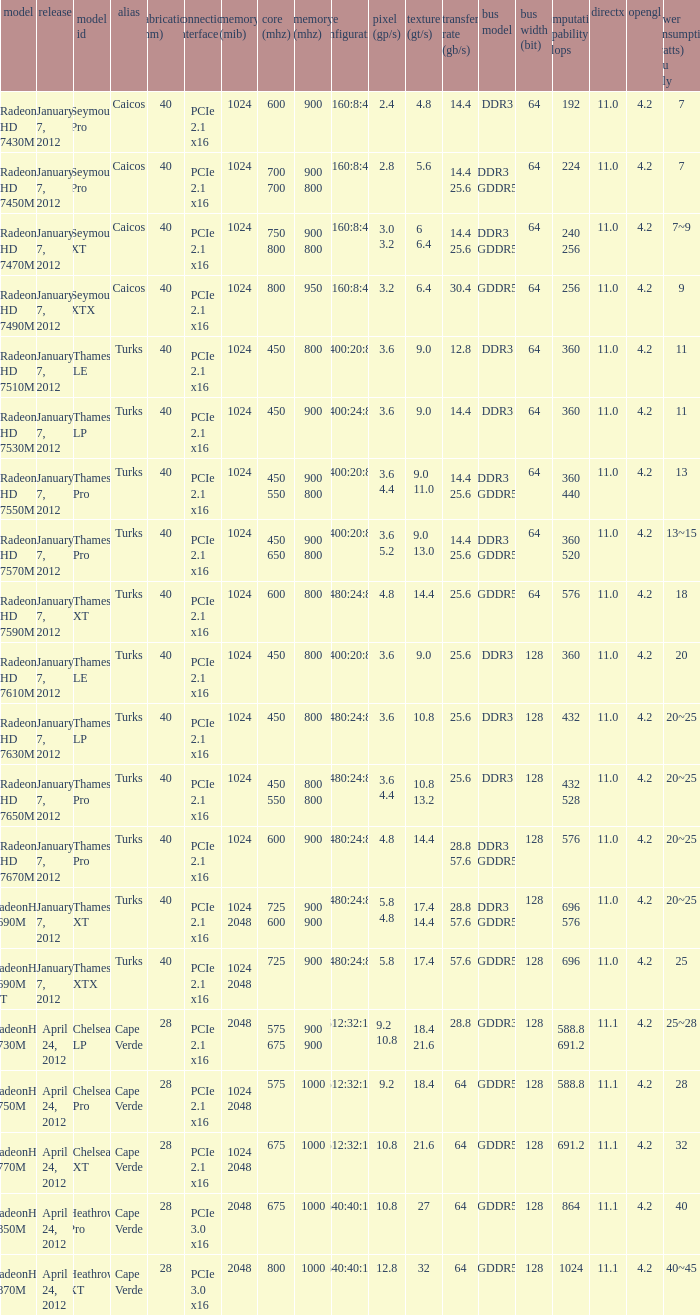I'm looking to parse the entire table for insights. Could you assist me with that? {'header': ['model', 'release', 'model id', 'alias', 'fabrication (nm)', 'connection interface', 'memory (mib)', 'core (mhz)', 'memory (mhz)', 'core configuration', 'pixel (gp/s)', 'texture (gt/s)', 'transfer rate (gb/s)', 'bus model', 'bus width (bit)', 'computation capability gflops', 'directx', 'opengl', 'power consumption (watts) gpu only'], 'rows': [['Radeon HD 7430M', 'January 7, 2012', 'Seymour Pro', 'Caicos', '40', 'PCIe 2.1 x16', '1024', '600', '900', '160:8:4', '2.4', '4.8', '14.4', 'DDR3', '64', '192', '11.0', '4.2', '7'], ['Radeon HD 7450M', 'January 7, 2012', 'Seymour Pro', 'Caicos', '40', 'PCIe 2.1 x16', '1024', '700 700', '900 800', '160:8:4', '2.8', '5.6', '14.4 25.6', 'DDR3 GDDR5', '64', '224', '11.0', '4.2', '7'], ['Radeon HD 7470M', 'January 7, 2012', 'Seymour XT', 'Caicos', '40', 'PCIe 2.1 x16', '1024', '750 800', '900 800', '160:8:4', '3.0 3.2', '6 6.4', '14.4 25.6', 'DDR3 GDDR5', '64', '240 256', '11.0', '4.2', '7~9'], ['Radeon HD 7490M', 'January 7, 2012', 'Seymour XTX', 'Caicos', '40', 'PCIe 2.1 x16', '1024', '800', '950', '160:8:4', '3.2', '6.4', '30.4', 'GDDR5', '64', '256', '11.0', '4.2', '9'], ['Radeon HD 7510M', 'January 7, 2012', 'Thames LE', 'Turks', '40', 'PCIe 2.1 x16', '1024', '450', '800', '400:20:8', '3.6', '9.0', '12.8', 'DDR3', '64', '360', '11.0', '4.2', '11'], ['Radeon HD 7530M', 'January 7, 2012', 'Thames LP', 'Turks', '40', 'PCIe 2.1 x16', '1024', '450', '900', '400:24:8', '3.6', '9.0', '14.4', 'DDR3', '64', '360', '11.0', '4.2', '11'], ['Radeon HD 7550M', 'January 7, 2012', 'Thames Pro', 'Turks', '40', 'PCIe 2.1 x16', '1024', '450 550', '900 800', '400:20:8', '3.6 4.4', '9.0 11.0', '14.4 25.6', 'DDR3 GDDR5', '64', '360 440', '11.0', '4.2', '13'], ['Radeon HD 7570M', 'January 7, 2012', 'Thames Pro', 'Turks', '40', 'PCIe 2.1 x16', '1024', '450 650', '900 800', '400:20:8', '3.6 5.2', '9.0 13.0', '14.4 25.6', 'DDR3 GDDR5', '64', '360 520', '11.0', '4.2', '13~15'], ['Radeon HD 7590M', 'January 7, 2012', 'Thames XT', 'Turks', '40', 'PCIe 2.1 x16', '1024', '600', '800', '480:24:8', '4.8', '14.4', '25.6', 'GDDR5', '64', '576', '11.0', '4.2', '18'], ['Radeon HD 7610M', 'January 7, 2012', 'Thames LE', 'Turks', '40', 'PCIe 2.1 x16', '1024', '450', '800', '400:20:8', '3.6', '9.0', '25.6', 'DDR3', '128', '360', '11.0', '4.2', '20'], ['Radeon HD 7630M', 'January 7, 2012', 'Thames LP', 'Turks', '40', 'PCIe 2.1 x16', '1024', '450', '800', '480:24:8', '3.6', '10.8', '25.6', 'DDR3', '128', '432', '11.0', '4.2', '20~25'], ['Radeon HD 7650M', 'January 7, 2012', 'Thames Pro', 'Turks', '40', 'PCIe 2.1 x16', '1024', '450 550', '800 800', '480:24:8', '3.6 4.4', '10.8 13.2', '25.6', 'DDR3', '128', '432 528', '11.0', '4.2', '20~25'], ['Radeon HD 7670M', 'January 7, 2012', 'Thames Pro', 'Turks', '40', 'PCIe 2.1 x16', '1024', '600', '900', '480:24:8', '4.8', '14.4', '28.8 57.6', 'DDR3 GDDR5', '128', '576', '11.0', '4.2', '20~25'], ['RadeonHD 7690M', 'January 7, 2012', 'Thames XT', 'Turks', '40', 'PCIe 2.1 x16', '1024 2048', '725 600', '900 900', '480:24:8', '5.8 4.8', '17.4 14.4', '28.8 57.6', 'DDR3 GDDR5', '128', '696 576', '11.0', '4.2', '20~25'], ['RadeonHD 7690M XT', 'January 7, 2012', 'Thames XTX', 'Turks', '40', 'PCIe 2.1 x16', '1024 2048', '725', '900', '480:24:8', '5.8', '17.4', '57.6', 'GDDR5', '128', '696', '11.0', '4.2', '25'], ['RadeonHD 7730M', 'April 24, 2012', 'Chelsea LP', 'Cape Verde', '28', 'PCIe 2.1 x16', '2048', '575 675', '900 900', '512:32:16', '9.2 10.8', '18.4 21.6', '28.8', 'GDDR3', '128', '588.8 691.2', '11.1', '4.2', '25~28'], ['RadeonHD 7750M', 'April 24, 2012', 'Chelsea Pro', 'Cape Verde', '28', 'PCIe 2.1 x16', '1024 2048', '575', '1000', '512:32:16', '9.2', '18.4', '64', 'GDDR5', '128', '588.8', '11.1', '4.2', '28'], ['RadeonHD 7770M', 'April 24, 2012', 'Chelsea XT', 'Cape Verde', '28', 'PCIe 2.1 x16', '1024 2048', '675', '1000', '512:32:16', '10.8', '21.6', '64', 'GDDR5', '128', '691.2', '11.1', '4.2', '32'], ['RadeonHD 7850M', 'April 24, 2012', 'Heathrow Pro', 'Cape Verde', '28', 'PCIe 3.0 x16', '2048', '675', '1000', '640:40:16', '10.8', '27', '64', 'GDDR5', '128', '864', '11.1', '4.2', '40'], ['RadeonHD 7870M', 'April 24, 2012', 'Heathrow XT', 'Cape Verde', '28', 'PCIe 3.0 x16', '2048', '800', '1000', '640:40:16', '12.8', '32', '64', 'GDDR5', '128', '1024', '11.1', '4.2', '40~45']]} What was the model's DirectX if it has a Core of 700 700 mhz? 11.0. 